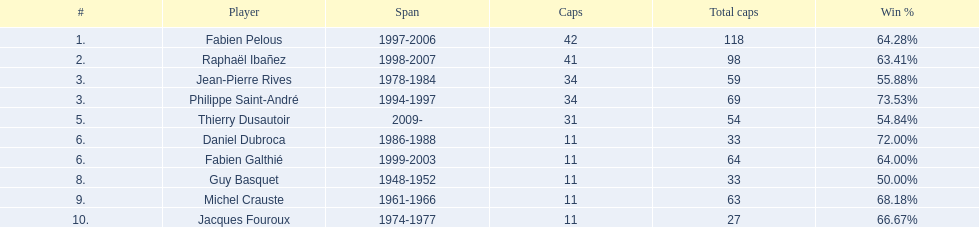Who had the largest win percentage? Philippe Saint-André. 